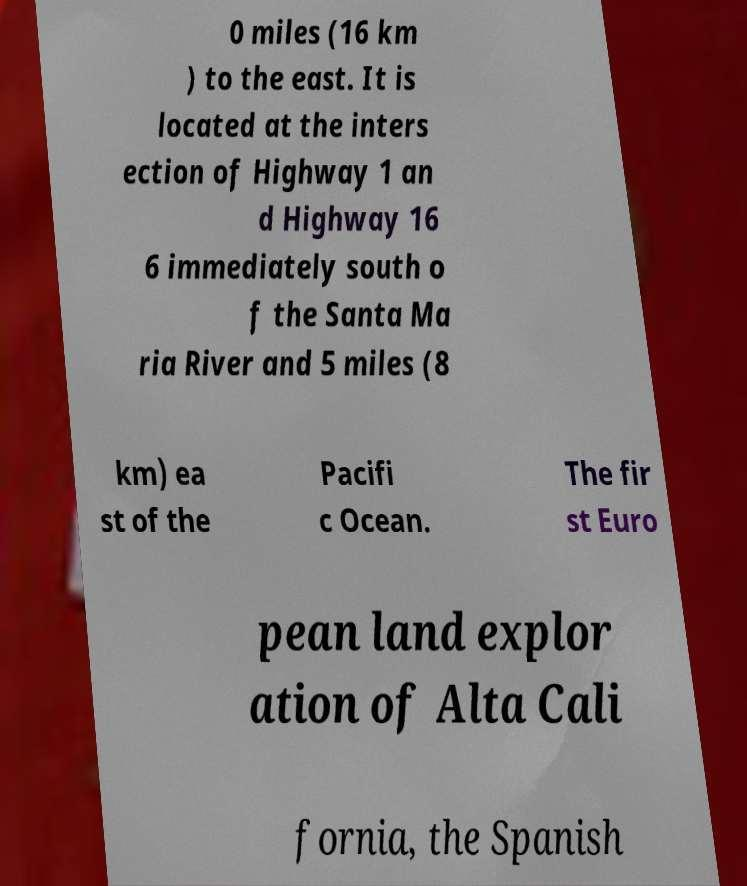Could you extract and type out the text from this image? 0 miles (16 km ) to the east. It is located at the inters ection of Highway 1 an d Highway 16 6 immediately south o f the Santa Ma ria River and 5 miles (8 km) ea st of the Pacifi c Ocean. The fir st Euro pean land explor ation of Alta Cali fornia, the Spanish 